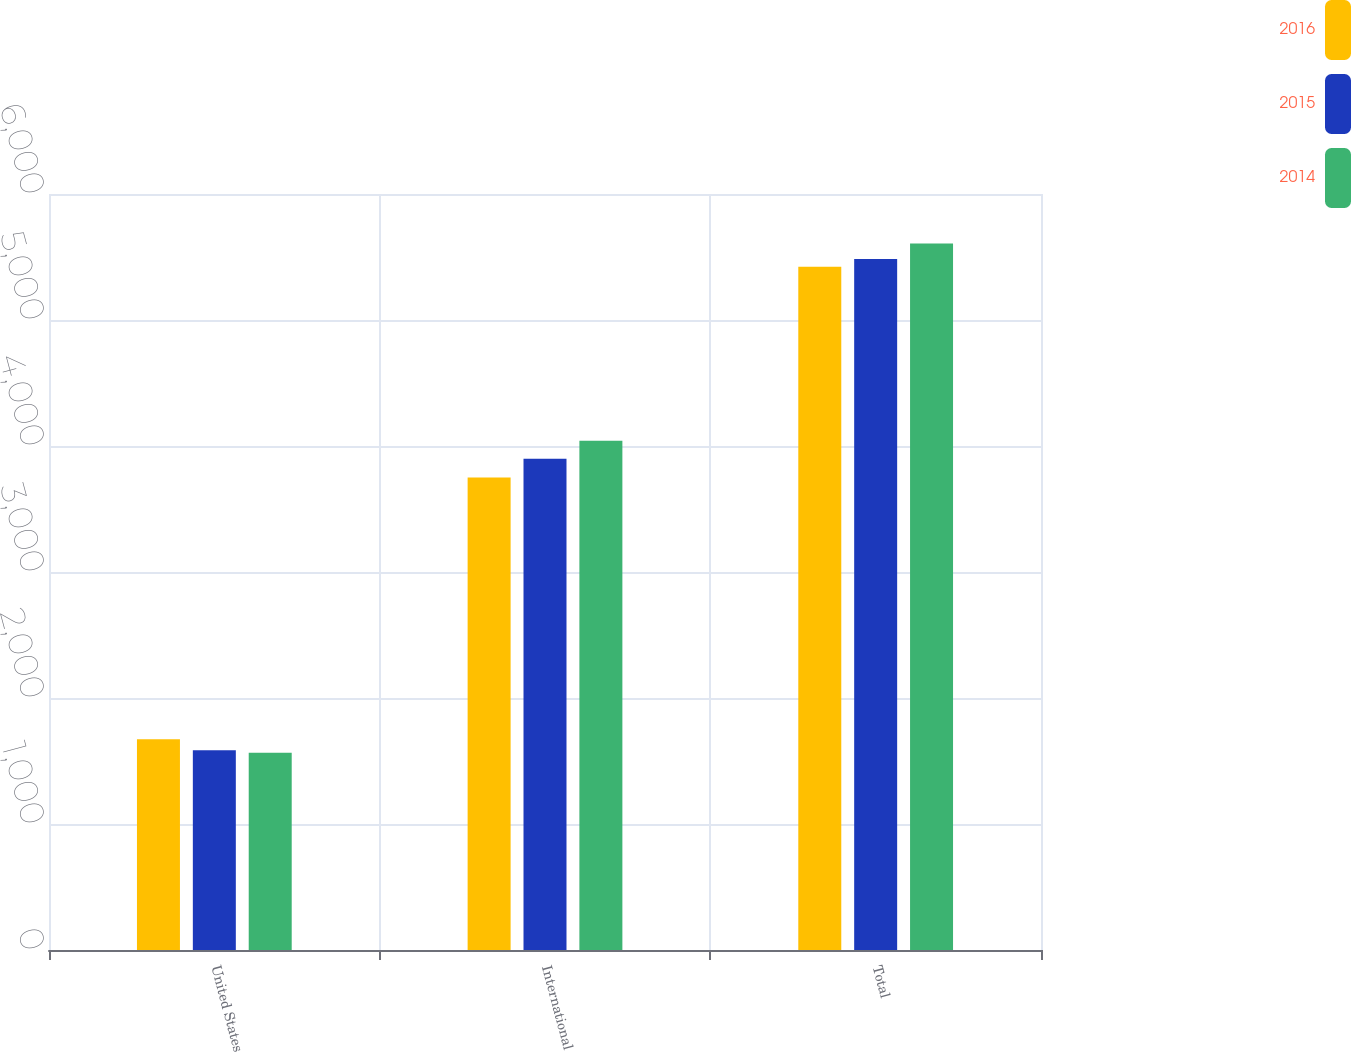<chart> <loc_0><loc_0><loc_500><loc_500><stacked_bar_chart><ecel><fcel>United States<fcel>International<fcel>Total<nl><fcel>2016<fcel>1672.9<fcel>3750<fcel>5422.9<nl><fcel>2015<fcel>1584.7<fcel>3899<fcel>5483.7<nl><fcel>2014<fcel>1564.6<fcel>4042.6<fcel>5607.2<nl></chart> 